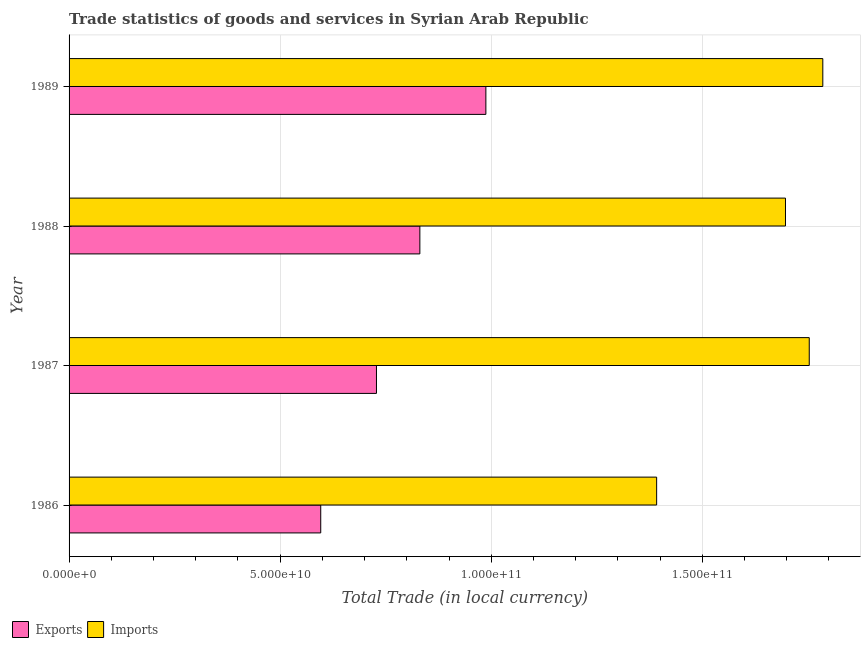How many different coloured bars are there?
Your answer should be very brief. 2. Are the number of bars per tick equal to the number of legend labels?
Make the answer very short. Yes. Are the number of bars on each tick of the Y-axis equal?
Ensure brevity in your answer.  Yes. How many bars are there on the 4th tick from the top?
Keep it short and to the point. 2. How many bars are there on the 2nd tick from the bottom?
Provide a succinct answer. 2. What is the export of goods and services in 1988?
Offer a terse response. 8.31e+1. Across all years, what is the maximum imports of goods and services?
Ensure brevity in your answer.  1.79e+11. Across all years, what is the minimum imports of goods and services?
Provide a succinct answer. 1.39e+11. In which year was the imports of goods and services maximum?
Provide a short and direct response. 1989. What is the total imports of goods and services in the graph?
Ensure brevity in your answer.  6.63e+11. What is the difference between the imports of goods and services in 1986 and that in 1987?
Keep it short and to the point. -3.61e+1. What is the difference between the imports of goods and services in 1986 and the export of goods and services in 1988?
Provide a short and direct response. 5.61e+1. What is the average imports of goods and services per year?
Offer a very short reply. 1.66e+11. In the year 1986, what is the difference between the export of goods and services and imports of goods and services?
Your answer should be compact. -7.96e+1. What is the ratio of the export of goods and services in 1986 to that in 1989?
Keep it short and to the point. 0.6. Is the export of goods and services in 1987 less than that in 1989?
Make the answer very short. Yes. What is the difference between the highest and the second highest imports of goods and services?
Make the answer very short. 3.21e+09. What is the difference between the highest and the lowest imports of goods and services?
Your answer should be compact. 3.94e+1. In how many years, is the imports of goods and services greater than the average imports of goods and services taken over all years?
Your answer should be very brief. 3. What does the 1st bar from the top in 1986 represents?
Offer a terse response. Imports. What does the 1st bar from the bottom in 1989 represents?
Offer a very short reply. Exports. How many bars are there?
Offer a very short reply. 8. How many years are there in the graph?
Offer a very short reply. 4. What is the difference between two consecutive major ticks on the X-axis?
Your response must be concise. 5.00e+1. Does the graph contain any zero values?
Keep it short and to the point. No. Does the graph contain grids?
Provide a succinct answer. Yes. How many legend labels are there?
Your answer should be very brief. 2. What is the title of the graph?
Make the answer very short. Trade statistics of goods and services in Syrian Arab Republic. What is the label or title of the X-axis?
Provide a succinct answer. Total Trade (in local currency). What is the Total Trade (in local currency) in Exports in 1986?
Ensure brevity in your answer.  5.96e+1. What is the Total Trade (in local currency) of Imports in 1986?
Your answer should be very brief. 1.39e+11. What is the Total Trade (in local currency) of Exports in 1987?
Offer a terse response. 7.28e+1. What is the Total Trade (in local currency) in Imports in 1987?
Ensure brevity in your answer.  1.75e+11. What is the Total Trade (in local currency) of Exports in 1988?
Make the answer very short. 8.31e+1. What is the Total Trade (in local currency) in Imports in 1988?
Give a very brief answer. 1.70e+11. What is the Total Trade (in local currency) in Exports in 1989?
Ensure brevity in your answer.  9.87e+1. What is the Total Trade (in local currency) in Imports in 1989?
Your answer should be very brief. 1.79e+11. Across all years, what is the maximum Total Trade (in local currency) in Exports?
Offer a terse response. 9.87e+1. Across all years, what is the maximum Total Trade (in local currency) in Imports?
Provide a succinct answer. 1.79e+11. Across all years, what is the minimum Total Trade (in local currency) in Exports?
Offer a terse response. 5.96e+1. Across all years, what is the minimum Total Trade (in local currency) in Imports?
Ensure brevity in your answer.  1.39e+11. What is the total Total Trade (in local currency) of Exports in the graph?
Offer a very short reply. 3.14e+11. What is the total Total Trade (in local currency) in Imports in the graph?
Provide a short and direct response. 6.63e+11. What is the difference between the Total Trade (in local currency) of Exports in 1986 and that in 1987?
Offer a very short reply. -1.32e+1. What is the difference between the Total Trade (in local currency) in Imports in 1986 and that in 1987?
Your response must be concise. -3.61e+1. What is the difference between the Total Trade (in local currency) of Exports in 1986 and that in 1988?
Your answer should be compact. -2.35e+1. What is the difference between the Total Trade (in local currency) of Imports in 1986 and that in 1988?
Your answer should be very brief. -3.05e+1. What is the difference between the Total Trade (in local currency) of Exports in 1986 and that in 1989?
Offer a very short reply. -3.91e+1. What is the difference between the Total Trade (in local currency) of Imports in 1986 and that in 1989?
Your answer should be compact. -3.94e+1. What is the difference between the Total Trade (in local currency) in Exports in 1987 and that in 1988?
Ensure brevity in your answer.  -1.03e+1. What is the difference between the Total Trade (in local currency) in Imports in 1987 and that in 1988?
Make the answer very short. 5.63e+09. What is the difference between the Total Trade (in local currency) of Exports in 1987 and that in 1989?
Keep it short and to the point. -2.59e+1. What is the difference between the Total Trade (in local currency) of Imports in 1987 and that in 1989?
Your answer should be very brief. -3.21e+09. What is the difference between the Total Trade (in local currency) in Exports in 1988 and that in 1989?
Provide a short and direct response. -1.56e+1. What is the difference between the Total Trade (in local currency) of Imports in 1988 and that in 1989?
Give a very brief answer. -8.84e+09. What is the difference between the Total Trade (in local currency) of Exports in 1986 and the Total Trade (in local currency) of Imports in 1987?
Provide a succinct answer. -1.16e+11. What is the difference between the Total Trade (in local currency) of Exports in 1986 and the Total Trade (in local currency) of Imports in 1988?
Your answer should be very brief. -1.10e+11. What is the difference between the Total Trade (in local currency) in Exports in 1986 and the Total Trade (in local currency) in Imports in 1989?
Offer a very short reply. -1.19e+11. What is the difference between the Total Trade (in local currency) in Exports in 1987 and the Total Trade (in local currency) in Imports in 1988?
Offer a terse response. -9.69e+1. What is the difference between the Total Trade (in local currency) of Exports in 1987 and the Total Trade (in local currency) of Imports in 1989?
Offer a very short reply. -1.06e+11. What is the difference between the Total Trade (in local currency) of Exports in 1988 and the Total Trade (in local currency) of Imports in 1989?
Your response must be concise. -9.54e+1. What is the average Total Trade (in local currency) in Exports per year?
Provide a succinct answer. 7.86e+1. What is the average Total Trade (in local currency) in Imports per year?
Offer a very short reply. 1.66e+11. In the year 1986, what is the difference between the Total Trade (in local currency) in Exports and Total Trade (in local currency) in Imports?
Ensure brevity in your answer.  -7.96e+1. In the year 1987, what is the difference between the Total Trade (in local currency) of Exports and Total Trade (in local currency) of Imports?
Make the answer very short. -1.03e+11. In the year 1988, what is the difference between the Total Trade (in local currency) of Exports and Total Trade (in local currency) of Imports?
Keep it short and to the point. -8.66e+1. In the year 1989, what is the difference between the Total Trade (in local currency) in Exports and Total Trade (in local currency) in Imports?
Provide a succinct answer. -7.98e+1. What is the ratio of the Total Trade (in local currency) of Exports in 1986 to that in 1987?
Make the answer very short. 0.82. What is the ratio of the Total Trade (in local currency) in Imports in 1986 to that in 1987?
Provide a short and direct response. 0.79. What is the ratio of the Total Trade (in local currency) of Exports in 1986 to that in 1988?
Keep it short and to the point. 0.72. What is the ratio of the Total Trade (in local currency) in Imports in 1986 to that in 1988?
Provide a succinct answer. 0.82. What is the ratio of the Total Trade (in local currency) of Exports in 1986 to that in 1989?
Your answer should be compact. 0.6. What is the ratio of the Total Trade (in local currency) in Imports in 1986 to that in 1989?
Offer a very short reply. 0.78. What is the ratio of the Total Trade (in local currency) in Exports in 1987 to that in 1988?
Keep it short and to the point. 0.88. What is the ratio of the Total Trade (in local currency) of Imports in 1987 to that in 1988?
Your answer should be very brief. 1.03. What is the ratio of the Total Trade (in local currency) in Exports in 1987 to that in 1989?
Offer a very short reply. 0.74. What is the ratio of the Total Trade (in local currency) in Imports in 1987 to that in 1989?
Your answer should be compact. 0.98. What is the ratio of the Total Trade (in local currency) of Exports in 1988 to that in 1989?
Offer a very short reply. 0.84. What is the ratio of the Total Trade (in local currency) in Imports in 1988 to that in 1989?
Ensure brevity in your answer.  0.95. What is the difference between the highest and the second highest Total Trade (in local currency) in Exports?
Your answer should be very brief. 1.56e+1. What is the difference between the highest and the second highest Total Trade (in local currency) in Imports?
Offer a very short reply. 3.21e+09. What is the difference between the highest and the lowest Total Trade (in local currency) of Exports?
Your answer should be compact. 3.91e+1. What is the difference between the highest and the lowest Total Trade (in local currency) of Imports?
Make the answer very short. 3.94e+1. 